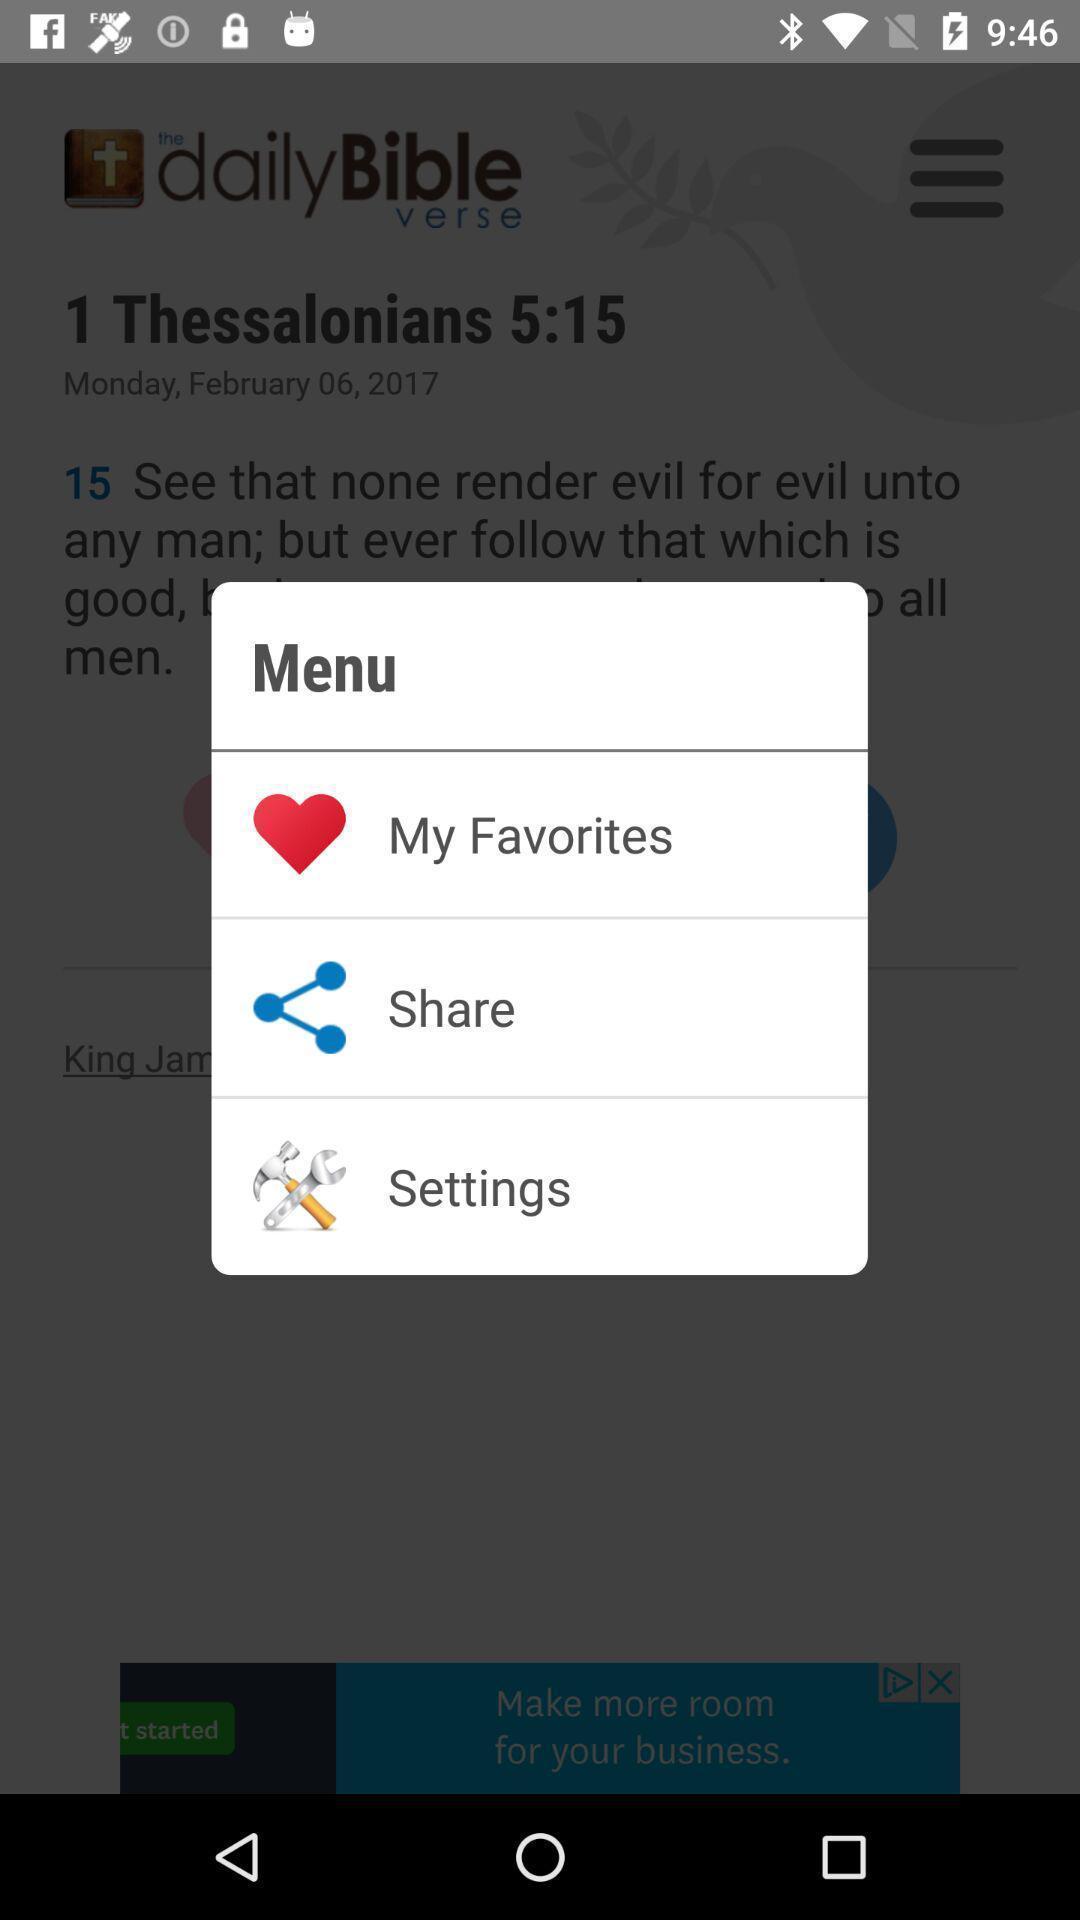Summarize the main components in this picture. Pop up showing menu options. 